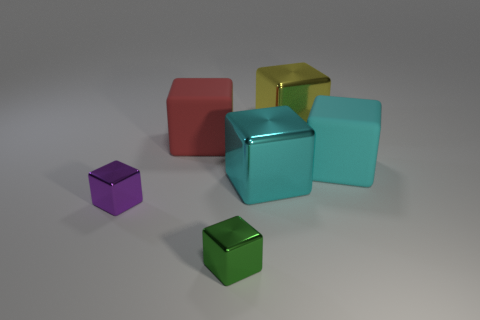How many other objects are the same size as the purple shiny object?
Give a very brief answer. 1. There is a large block left of the small green object; what is it made of?
Give a very brief answer. Rubber. What is the size of the red object that is the same shape as the small green metal object?
Your response must be concise. Large. How many other big blocks are made of the same material as the yellow block?
Ensure brevity in your answer.  1. What number of things are either objects right of the yellow shiny thing or small shiny objects behind the tiny green shiny object?
Your answer should be very brief. 2. Are there fewer cyan rubber things on the left side of the cyan shiny cube than big objects?
Give a very brief answer. Yes. Are there any other red matte cubes that have the same size as the red matte cube?
Ensure brevity in your answer.  No. Do the cyan rubber cube and the green metal cube have the same size?
Make the answer very short. No. How many objects are either yellow things or metal things?
Give a very brief answer. 4. Are there the same number of green shiny things behind the purple thing and tiny green things?
Your answer should be very brief. No. 